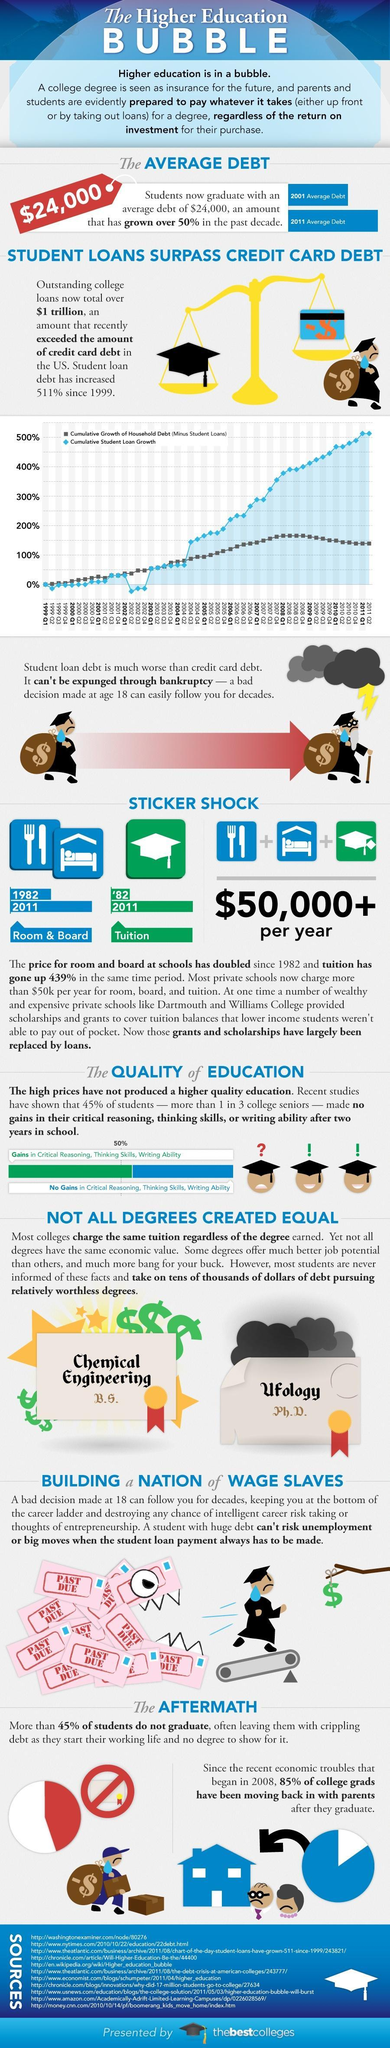How much is the cumulative student loan growth in 2009 Q4?
Answer the question with a short phrase. 450 Cumulative student loan growth was less than 0% for three consecutuve quarters of which year? 2002 Between 2001 and 2011 how much is the approximate increase in percentage of average student debt? 50% In which year did Cumulative student loan growth has surpassed 300% ? 2007 In which year did Cumulative student loan growth has surpassed 150% ? 2004 What is the cumulative growth of household debt , minus the student loan in second quarter of 2005? 100% How much is the cumulative student loan growth in third quarter of 2004? 150 What is the cumulative growth of household debt , minus the student loan in last quarter of 2009? 150 In which year did Cumulative student loan growth has surpassed 500% ? 2011 